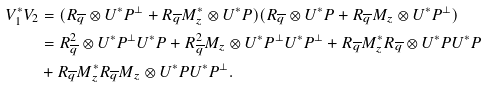Convert formula to latex. <formula><loc_0><loc_0><loc_500><loc_500>V _ { 1 } ^ { * } V _ { 2 } & = ( R _ { \overline { q } } \otimes U ^ { * } P ^ { \perp } + R _ { \overline { q } } M _ { z } ^ { * } \otimes U ^ { * } P ) ( R _ { \overline { q } } \otimes U ^ { * } P + R _ { \overline { q } } M _ { z } \otimes U ^ { * } P ^ { \perp } ) \\ & = R _ { \overline { q } } ^ { 2 } \otimes U ^ { * } P ^ { \perp } U ^ { * } P + R _ { \overline { q } } ^ { 2 } M _ { z } \otimes U ^ { * } P ^ { \perp } U ^ { * } P ^ { \perp } + R _ { \overline { q } } M _ { z } ^ { * } R _ { \overline { q } } \otimes U ^ { * } P U ^ { * } P \\ & + R _ { \overline { q } } M _ { z } ^ { * } R _ { \overline { q } } M _ { z } \otimes U ^ { * } P U ^ { * } P ^ { \perp } .</formula> 